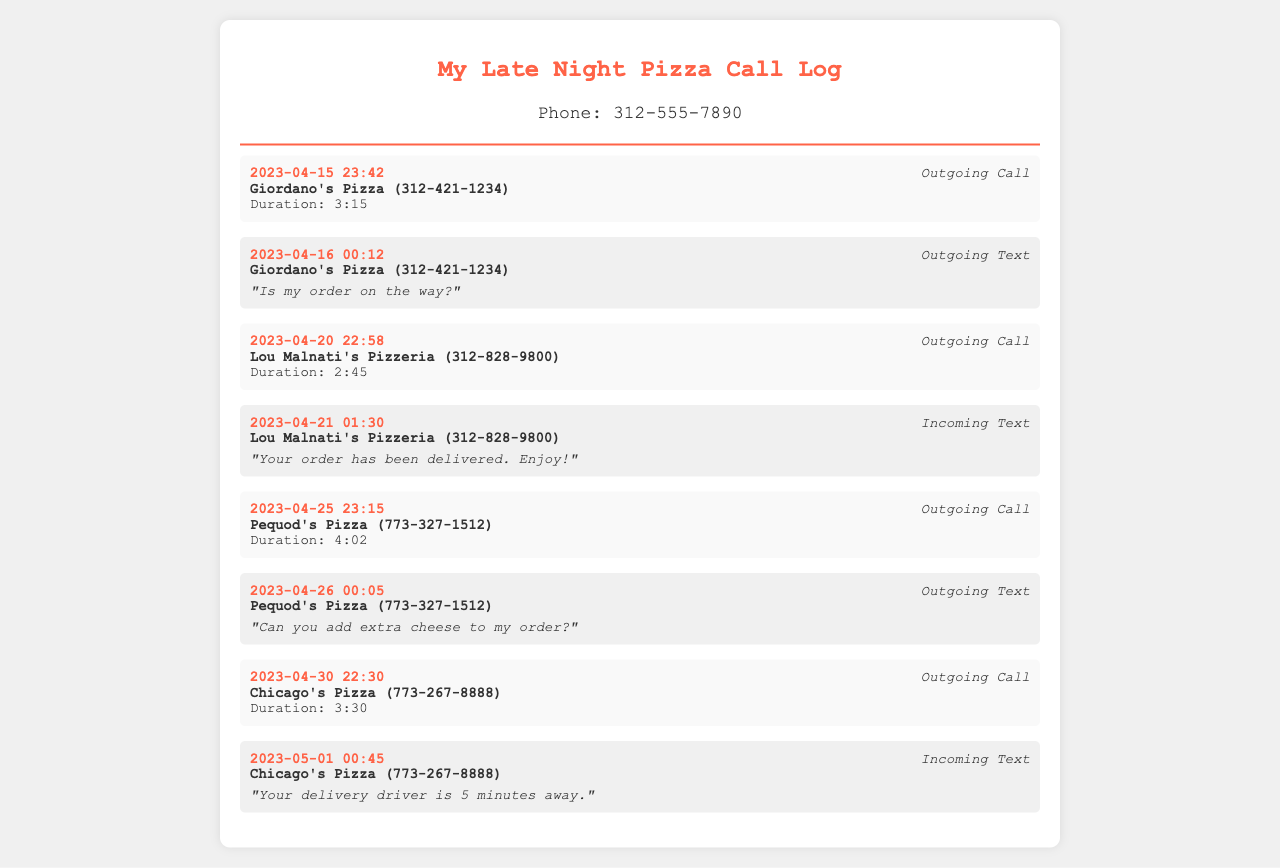what is the phone number associated with the log? The phone number is displayed at the top of the document in the phone-number section.
Answer: 312-555-7890 how many total outgoing calls are listed? The log entries indicate outgoing calls made to various pizza places; counting those entries gives the total.
Answer: 4 what is the duration of the call to Giordano's Pizza? The duration of the call is mentioned in the log entry for the call made to Giordano's Pizza.
Answer: 3:15 what time was the order from Pequod's Pizza placed? The log entry provides the specific date and time when the call was made to Pequod's Pizza.
Answer: 23:15 what message was received from Lou Malnati's Pizzeria? The content of the incoming text message from Lou Malnati's is provided in the log.
Answer: "Your order has been delivered. Enjoy!" how many texts were sent to pizza places? The logs include both outgoing texts and incoming texts to pizza places, so counting these entries gives the total.
Answer: 3 which pizza place is called last in the log? The last entry in the call log indicates the name of the pizza place called most recently.
Answer: Chicago's Pizza how many total contacts are referenced in the log? Each unique pizza place listed in the log counts as a separate contact, which can be determined by examining the entries.
Answer: 4 